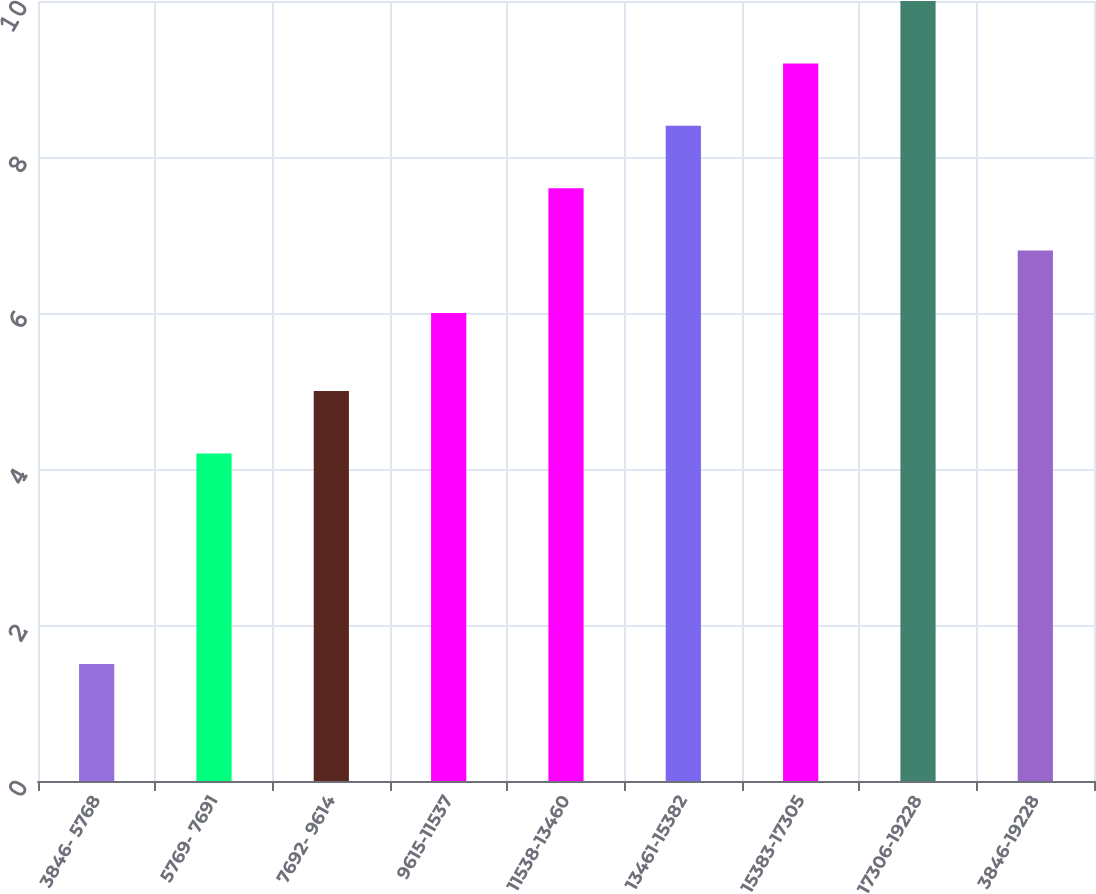<chart> <loc_0><loc_0><loc_500><loc_500><bar_chart><fcel>3846- 5768<fcel>5769- 7691<fcel>7692- 9614<fcel>9615-11537<fcel>11538-13460<fcel>13461-15382<fcel>15383-17305<fcel>17306-19228<fcel>3846-19228<nl><fcel>1.5<fcel>4.2<fcel>5<fcel>6<fcel>7.6<fcel>8.4<fcel>9.2<fcel>10<fcel>6.8<nl></chart> 